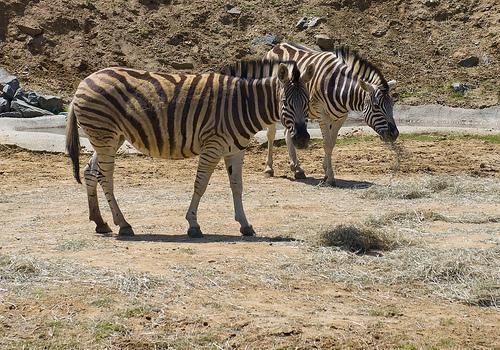How many zebras are there?
Give a very brief answer. 2. How many zebra tails are visible?
Give a very brief answer. 1. 